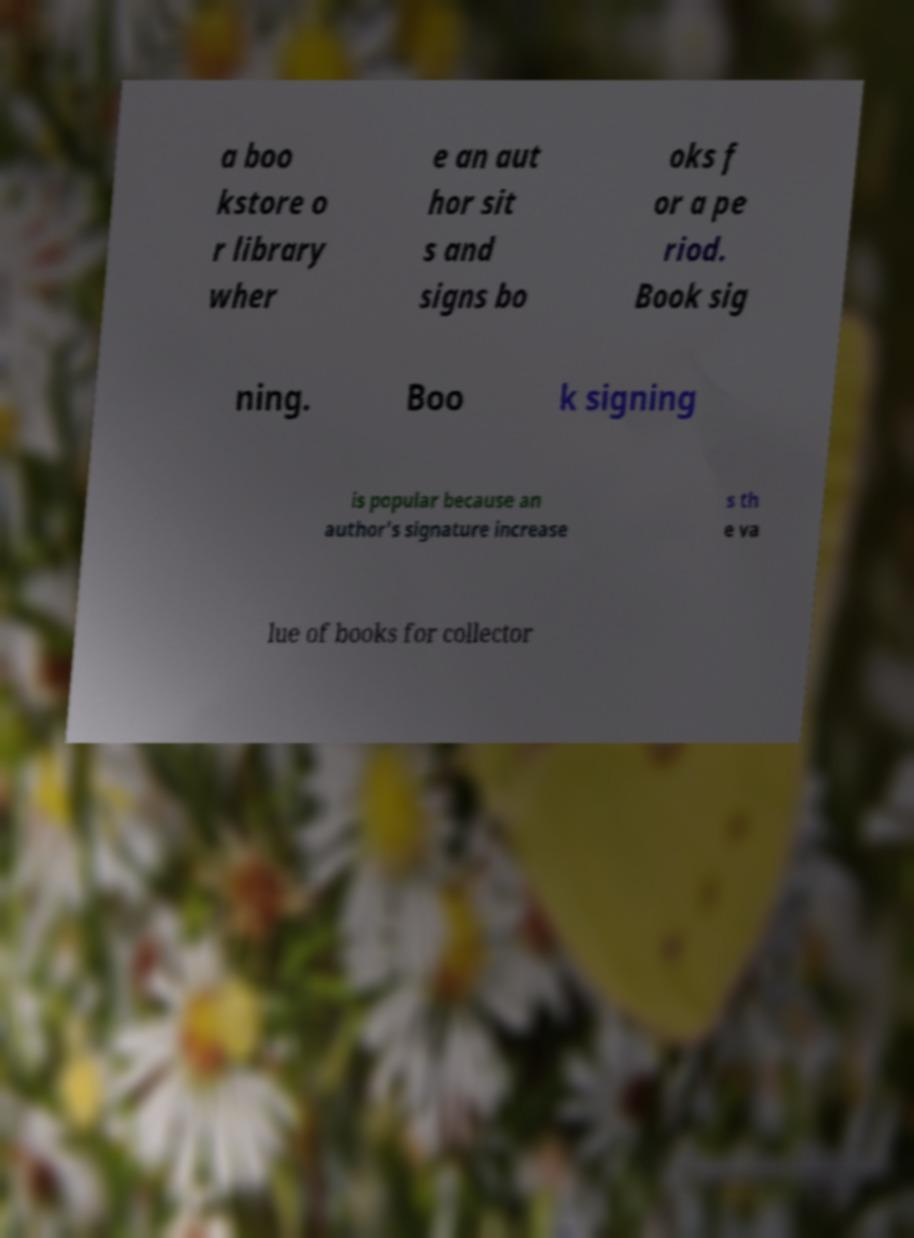Could you assist in decoding the text presented in this image and type it out clearly? a boo kstore o r library wher e an aut hor sit s and signs bo oks f or a pe riod. Book sig ning. Boo k signing is popular because an author's signature increase s th e va lue of books for collector 